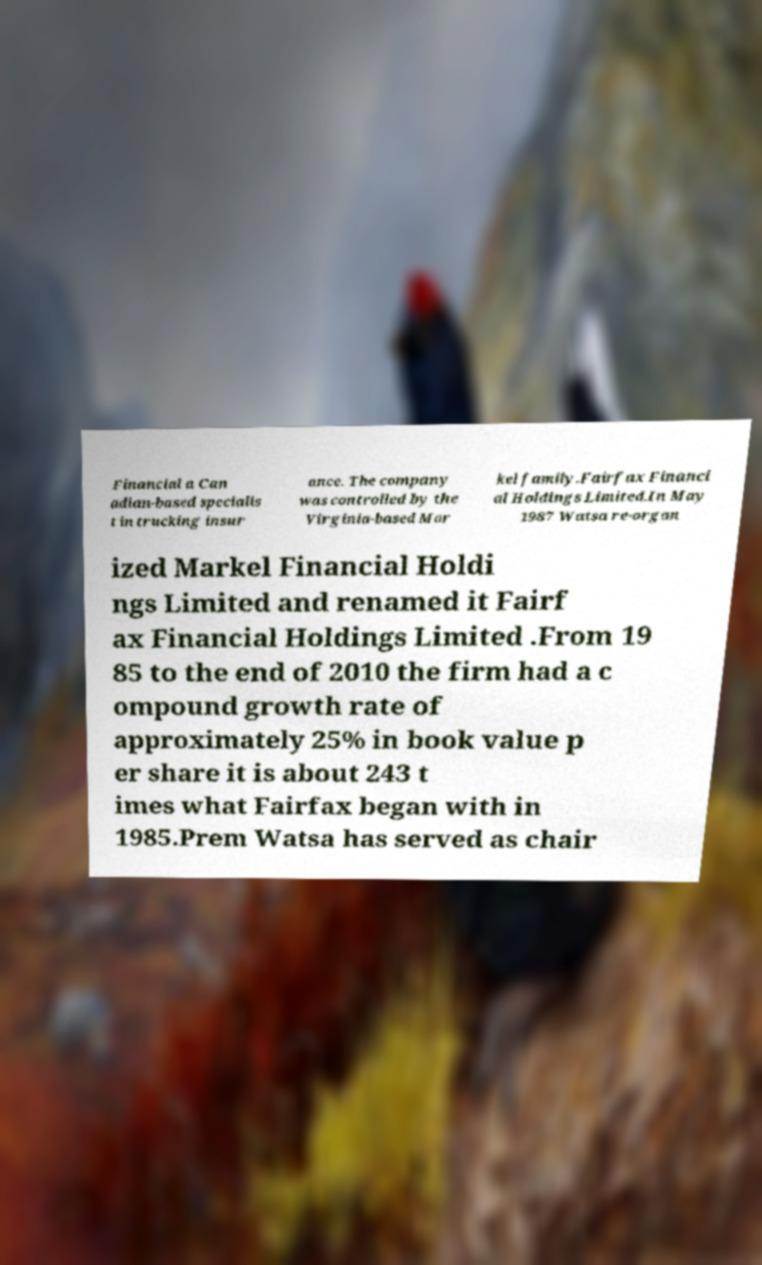Could you extract and type out the text from this image? Financial a Can adian-based specialis t in trucking insur ance. The company was controlled by the Virginia-based Mar kel family.Fairfax Financi al Holdings Limited.In May 1987 Watsa re-organ ized Markel Financial Holdi ngs Limited and renamed it Fairf ax Financial Holdings Limited .From 19 85 to the end of 2010 the firm had a c ompound growth rate of approximately 25% in book value p er share it is about 243 t imes what Fairfax began with in 1985.Prem Watsa has served as chair 